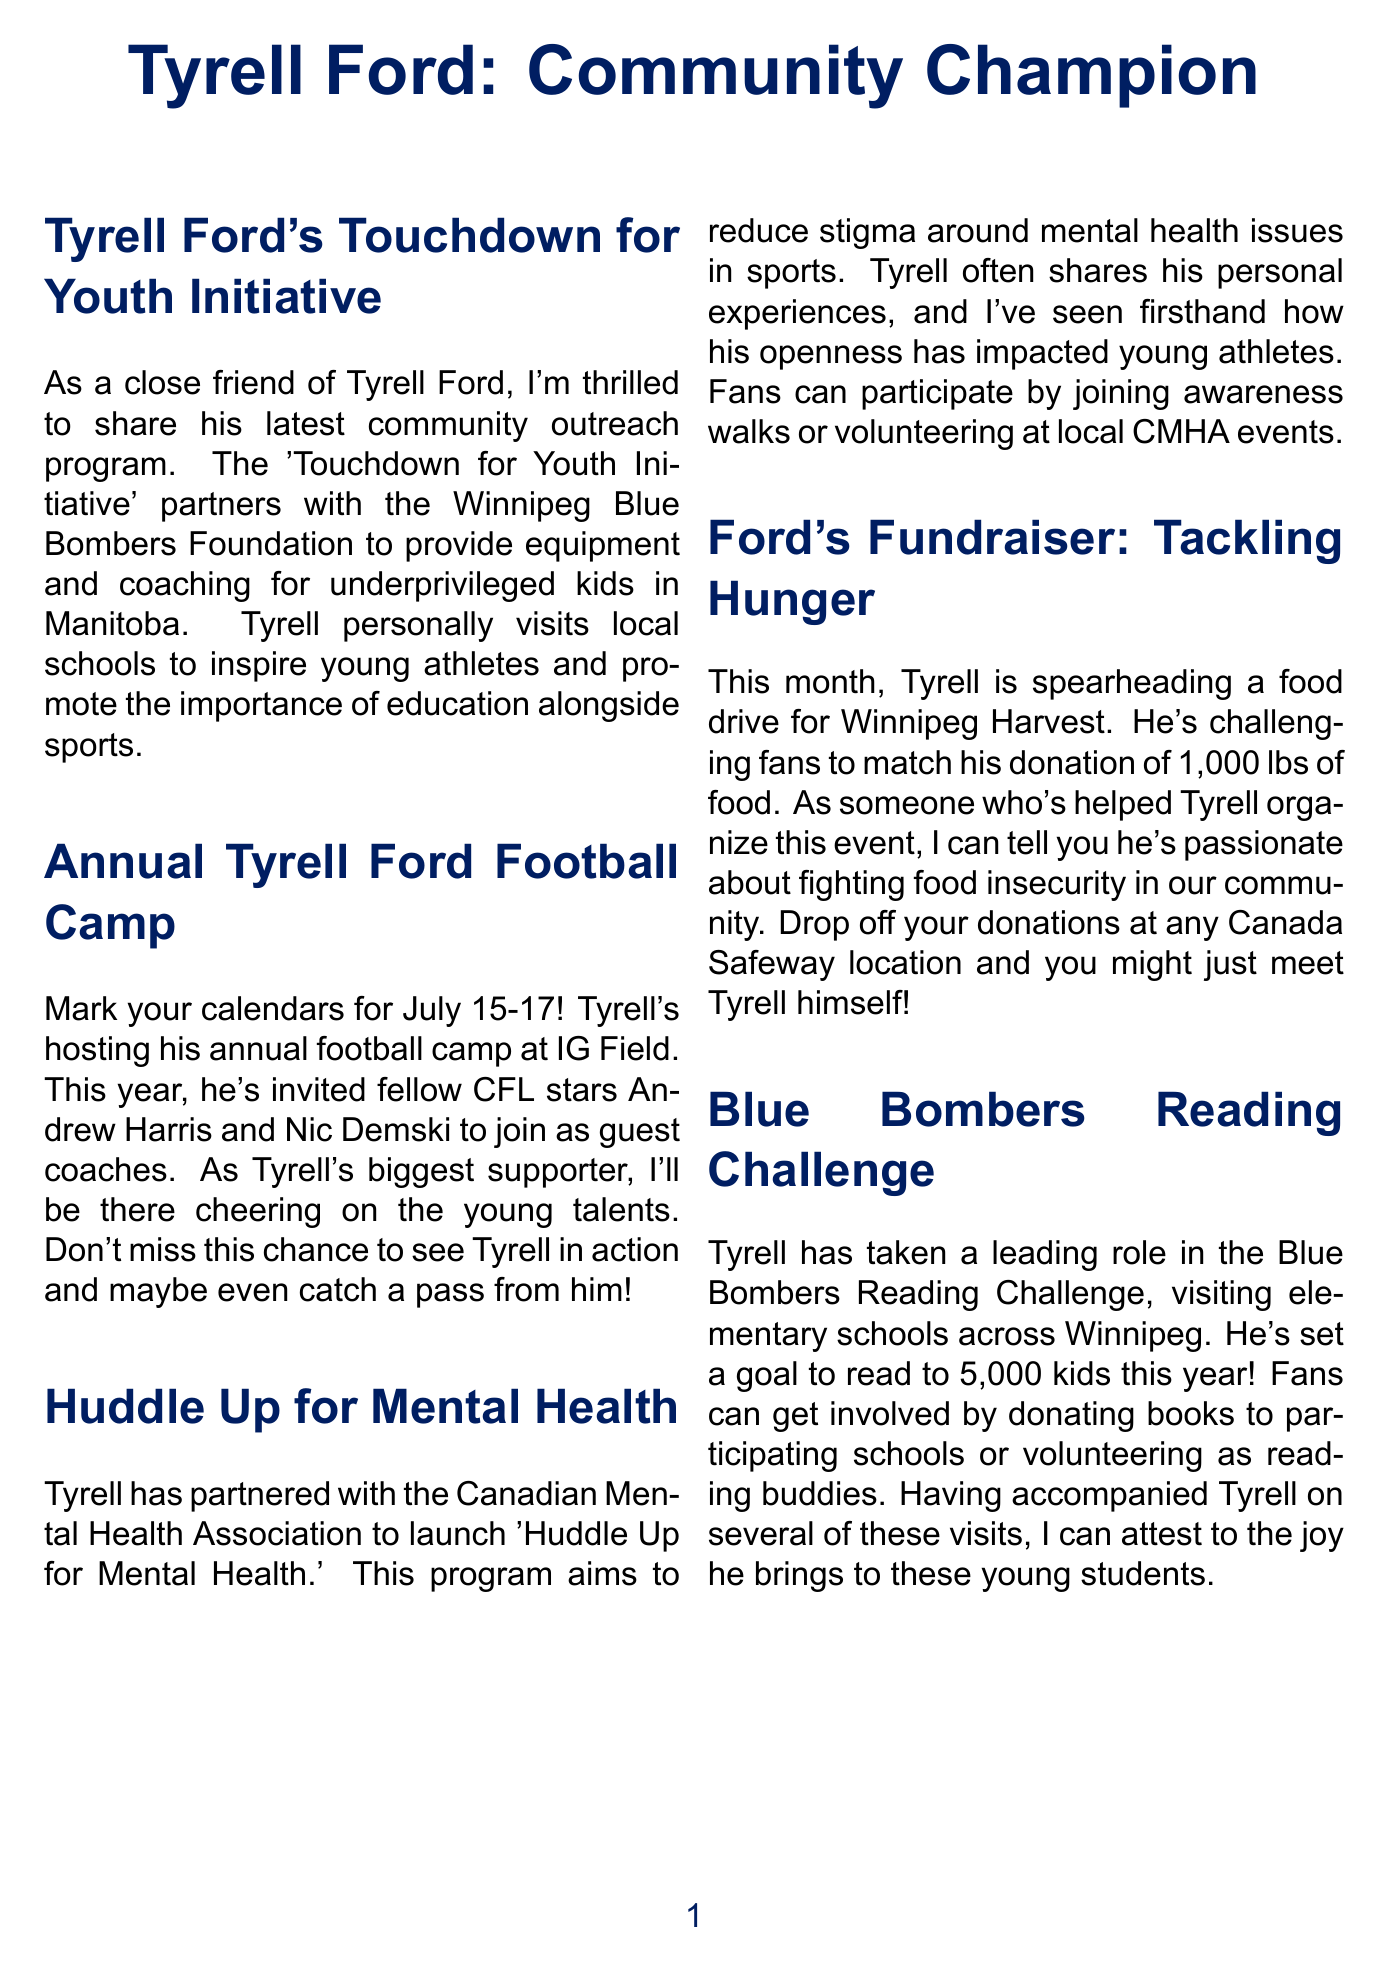What is the name of Tyrell's community outreach program? The outreach program is titled 'Touchdown for Youth Initiative.'
Answer: Touchdown for Youth Initiative When is the annual Tyrell Ford Football Camp taking place? The camp is scheduled for July 15-17.
Answer: July 15-17 Who are the guest coaches at the football camp? The guest coaches include Andrew Harris and Nic Demski.
Answer: Andrew Harris and Nic Demski What is the goal of the Blue Bombers Reading Challenge? The goal is to read to 5,000 kids this year.
Answer: 5,000 kids What organization has Tyrell partnered with for mental health awareness? Tyrell has partnered with the Canadian Mental Health Association.
Answer: Canadian Mental Health Association How much food is Tyrell challenging fans to donate? Tyrell is challenging fans to match his donation of 1,000 lbs of food.
Answer: 1,000 lbs What can fans do to participate in the 'Huddle Up for Mental Health' initiative? Fans can join awareness walks or volunteer at local CMHA events.
Answer: Join awareness walks or volunteer What is the primary cause of Tyrell's food drive? The food drive aims to tackle hunger in the community.
Answer: Tackling hunger Where can fans drop off their food donations? Donations can be dropped off at any Canada Safeway location.
Answer: Canada Safeway location 